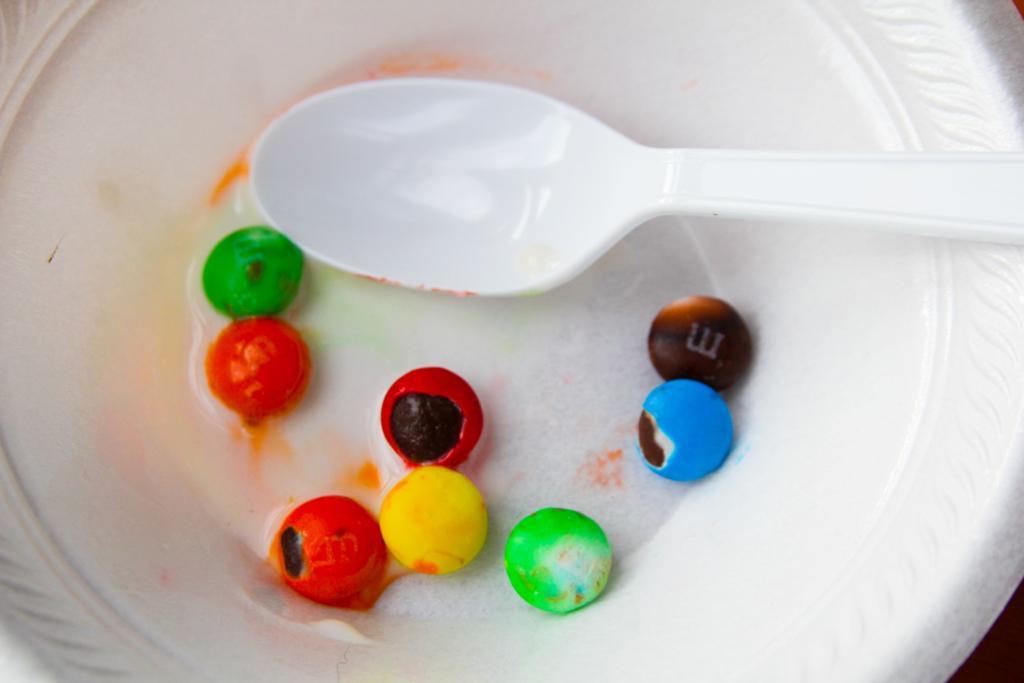How would you summarize this image in a sentence or two? In this picture there is a plate, spoon and gems. 